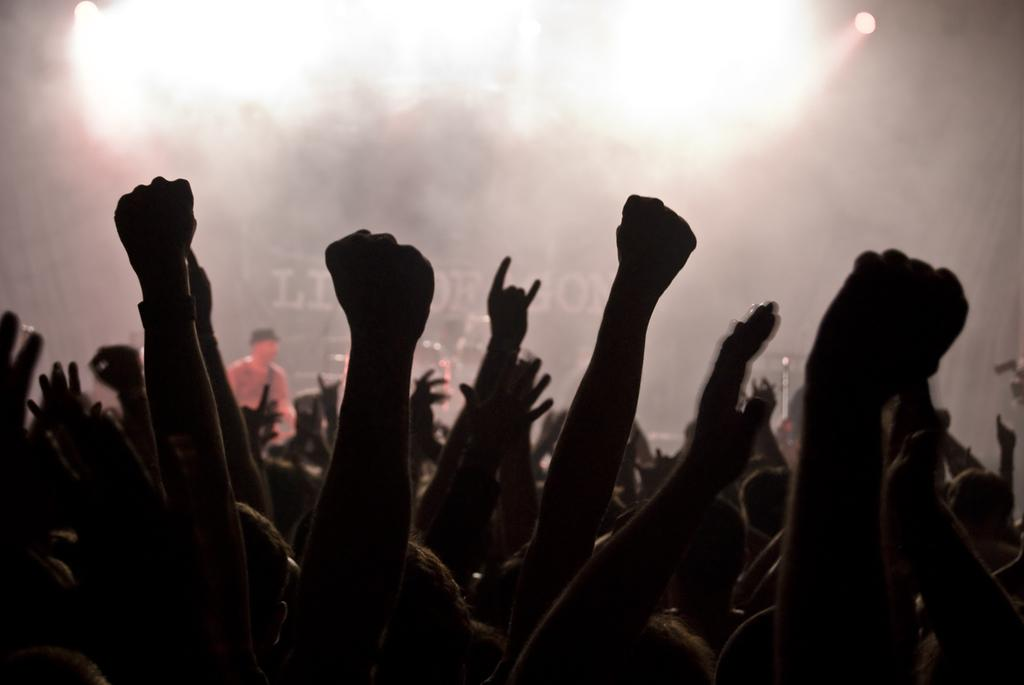How many people are visible in the image? There are persons standing in the image, but the exact number cannot be determined without more information. What is the smell of the eggnog in the image? There is no mention of eggnog in the image, so it cannot be determined if there is any eggnog present or what it might smell like. 